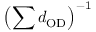<formula> <loc_0><loc_0><loc_500><loc_500>\left ( \sum d _ { O D } \right ) ^ { - 1 }</formula> 